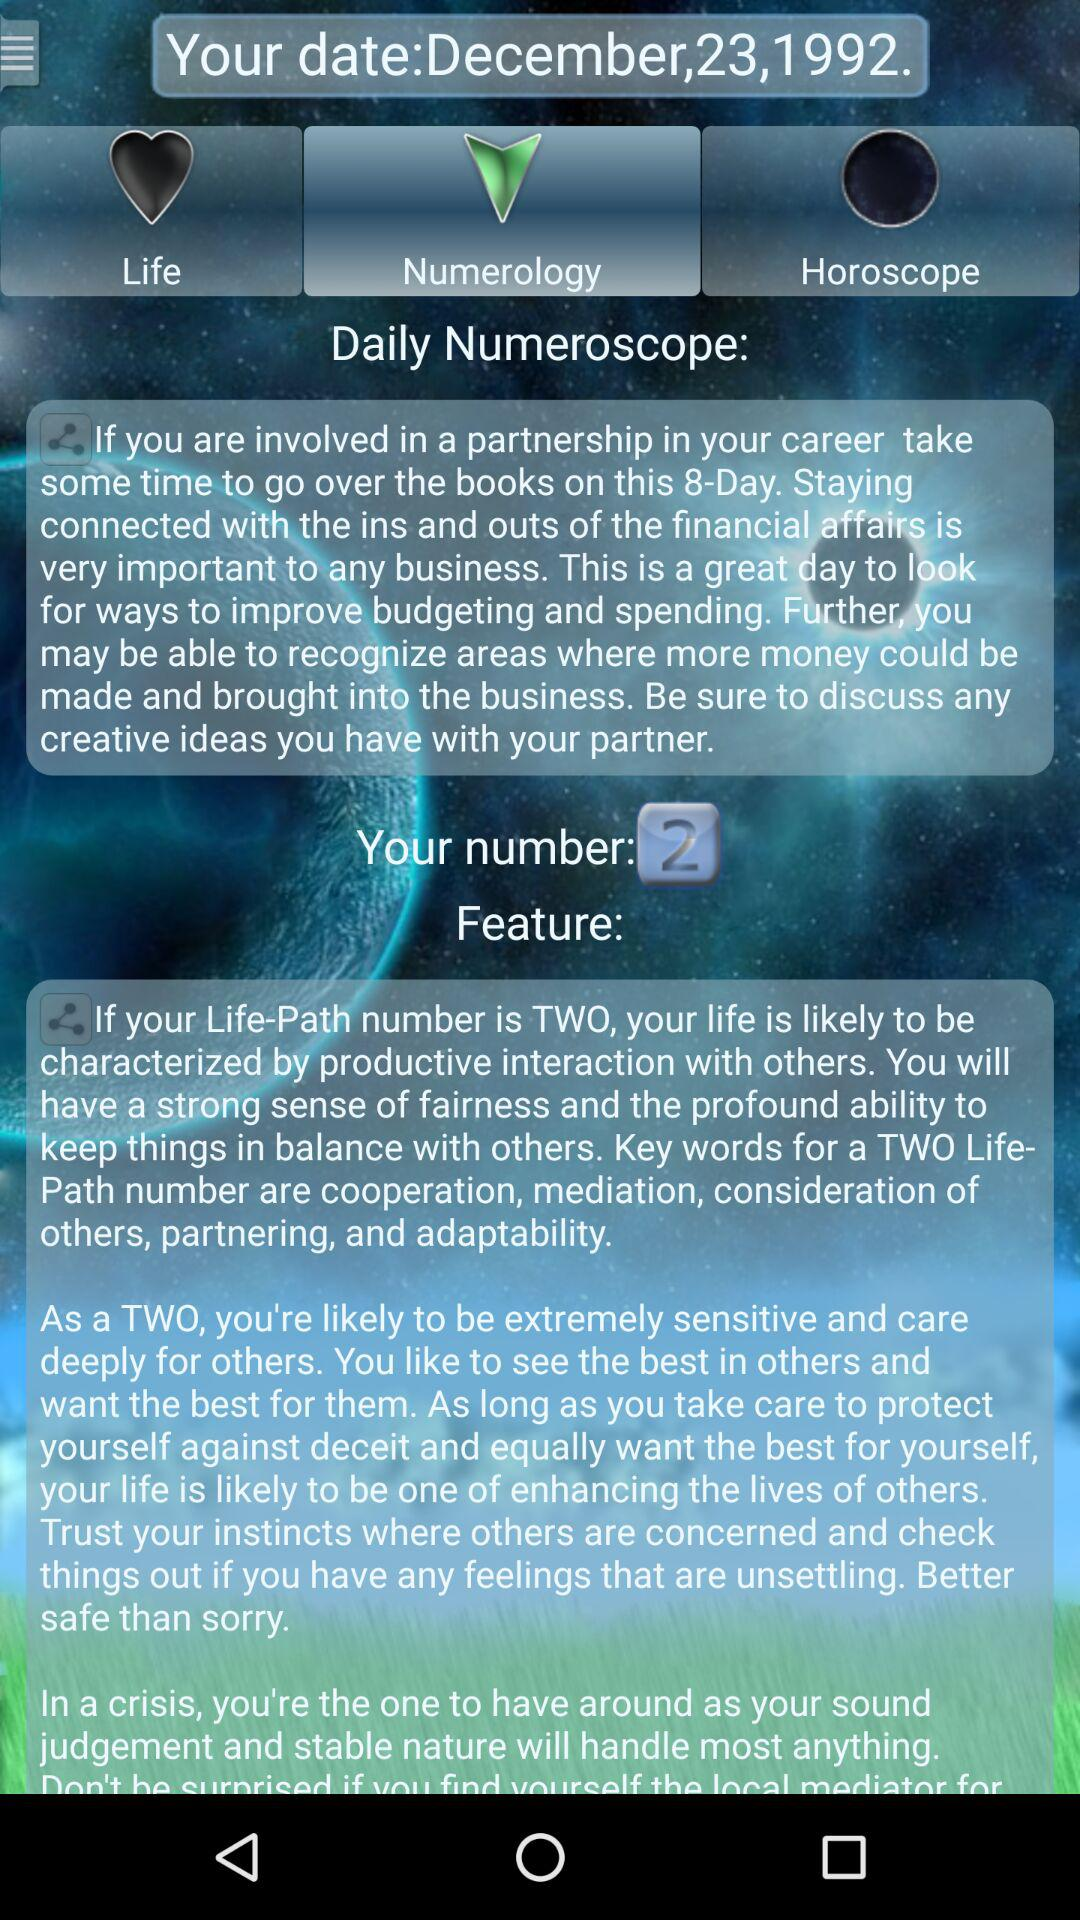What is my number? Your number is 2. 